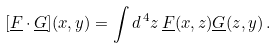Convert formula to latex. <formula><loc_0><loc_0><loc_500><loc_500>[ \underline { F } \cdot \underline { G } ] ( x , y ) = \int d ^ { \, 4 } z \, \underline { F } ( x , z ) \underline { G } ( z , y ) \, .</formula> 